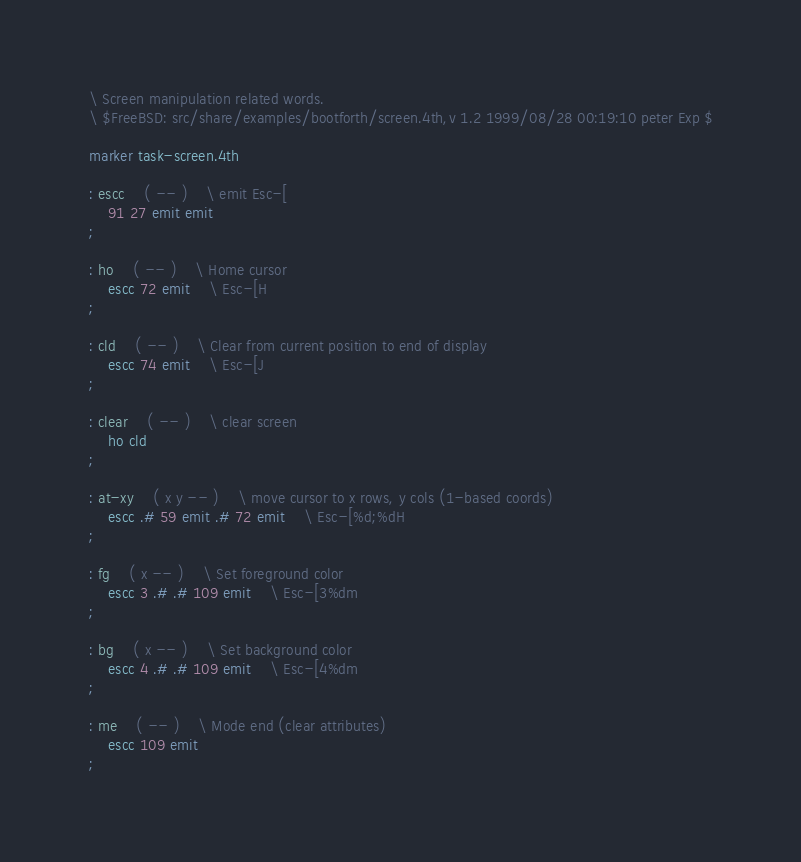Convert code to text. <code><loc_0><loc_0><loc_500><loc_500><_Forth_>\ Screen manipulation related words.
\ $FreeBSD: src/share/examples/bootforth/screen.4th,v 1.2 1999/08/28 00:19:10 peter Exp $

marker task-screen.4th

: escc	( -- )	\ emit Esc-[
	91 27 emit emit
;

: ho	( -- )	\ Home cursor
	escc 72 emit	\ Esc-[H
;

: cld	( -- )	\ Clear from current position to end of display
	escc 74 emit	\ Esc-[J
;

: clear	( -- )	\ clear screen
	ho cld
;

: at-xy	( x y -- )	\ move cursor to x rows, y cols (1-based coords)
	escc .# 59 emit .# 72 emit	\ Esc-[%d;%dH
;

: fg	( x -- )	\ Set foreground color
	escc 3 .# .# 109 emit	\ Esc-[3%dm
;

: bg	( x -- )	\ Set background color
	escc 4 .# .# 109 emit	\ Esc-[4%dm
;

: me	( -- )	\ Mode end (clear attributes)
	escc 109 emit
;
</code> 